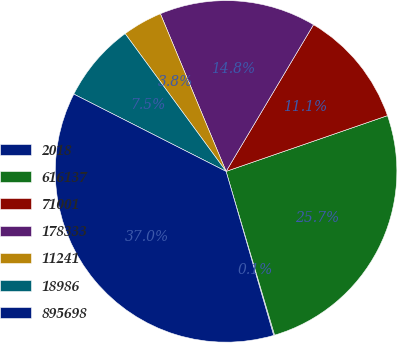Convert chart to OTSL. <chart><loc_0><loc_0><loc_500><loc_500><pie_chart><fcel>2018<fcel>616137<fcel>71001<fcel>178333<fcel>11241<fcel>18986<fcel>895698<nl><fcel>0.09%<fcel>25.71%<fcel>11.15%<fcel>14.84%<fcel>3.78%<fcel>7.46%<fcel>36.97%<nl></chart> 